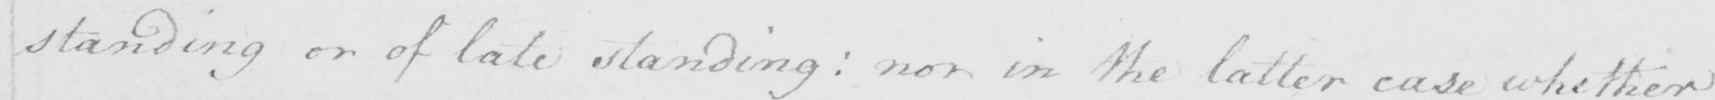What text is written in this handwritten line? standing or of late standing :  or in the latter case whether 